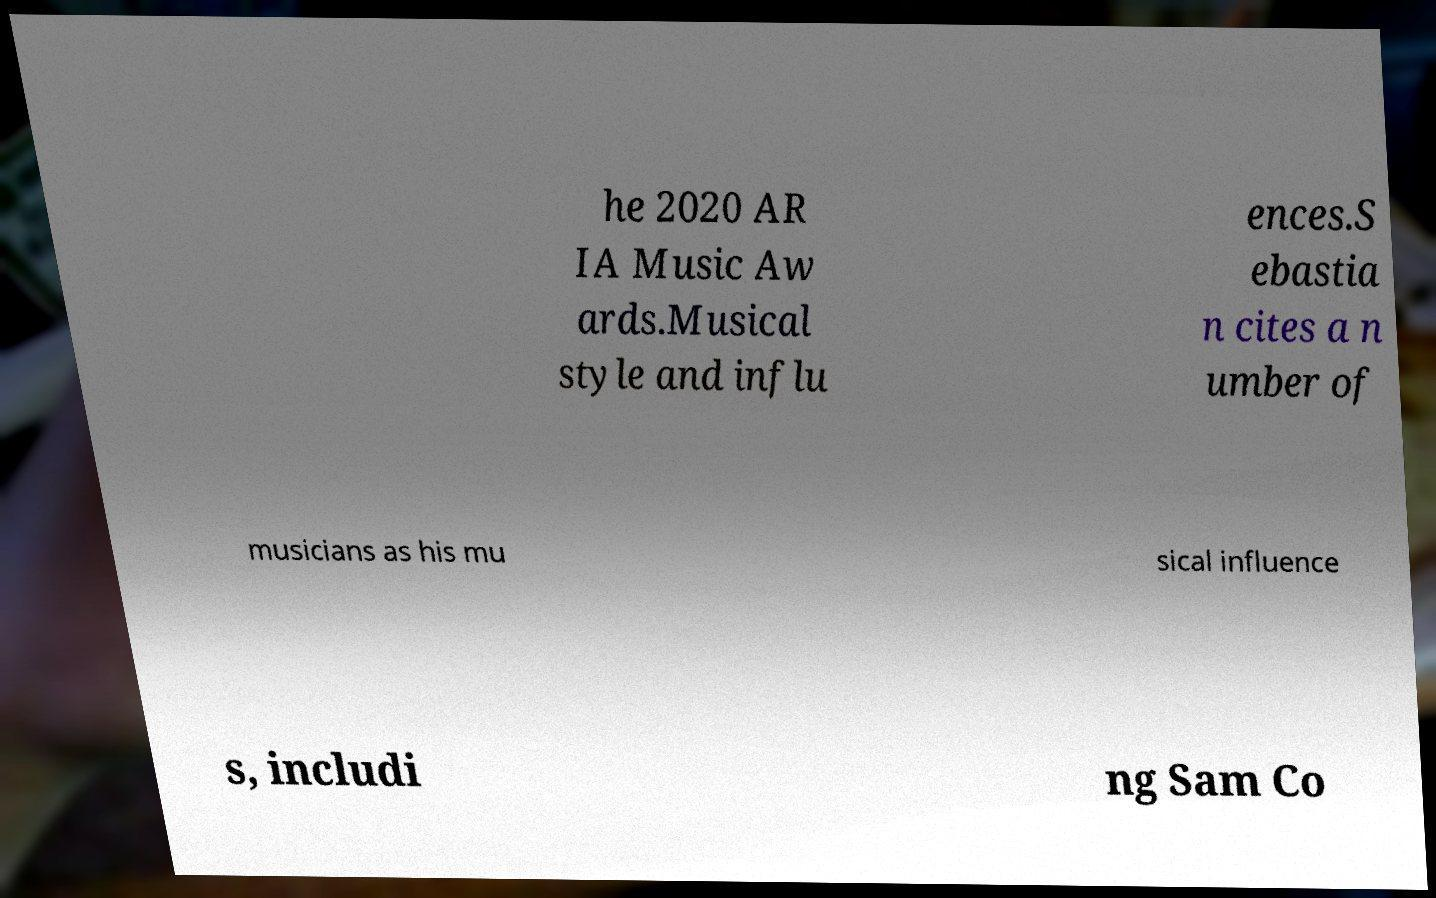For documentation purposes, I need the text within this image transcribed. Could you provide that? he 2020 AR IA Music Aw ards.Musical style and influ ences.S ebastia n cites a n umber of musicians as his mu sical influence s, includi ng Sam Co 